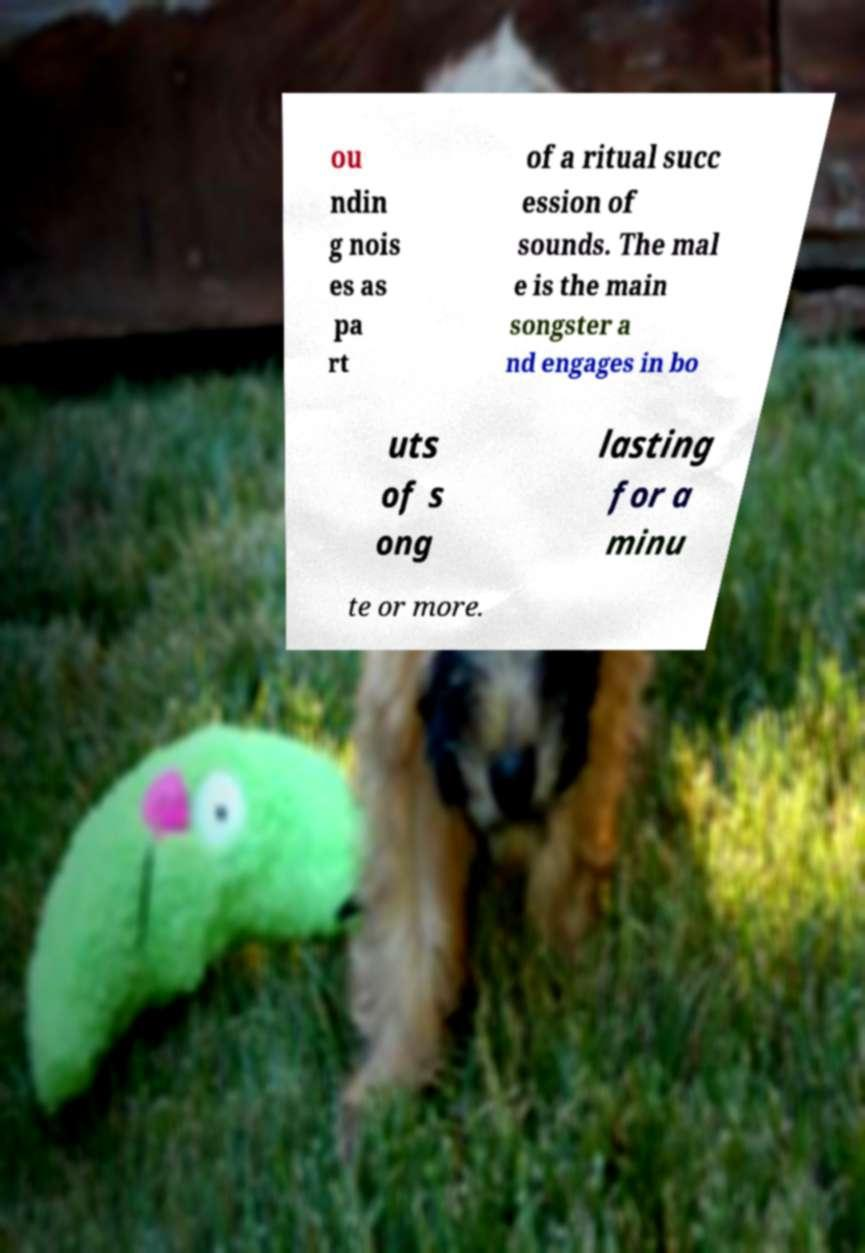Can you accurately transcribe the text from the provided image for me? ou ndin g nois es as pa rt of a ritual succ ession of sounds. The mal e is the main songster a nd engages in bo uts of s ong lasting for a minu te or more. 